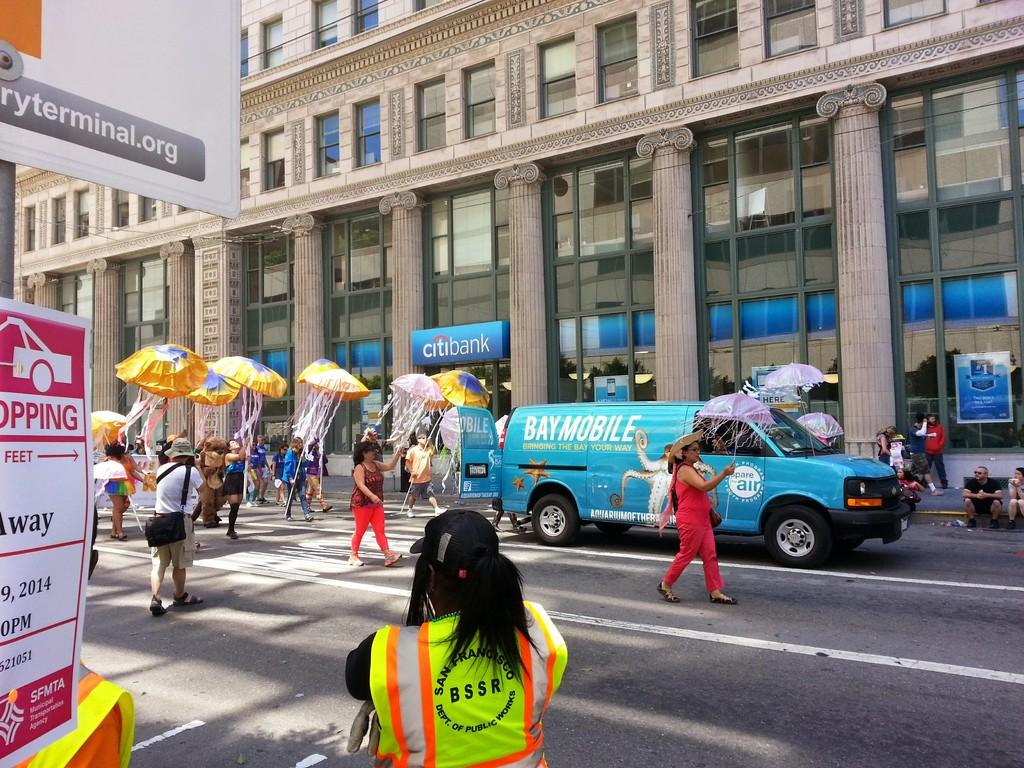<image>
Give a short and clear explanation of the subsequent image. A Baymobile van passes by the Citibank building, with several people walking behind the van. 